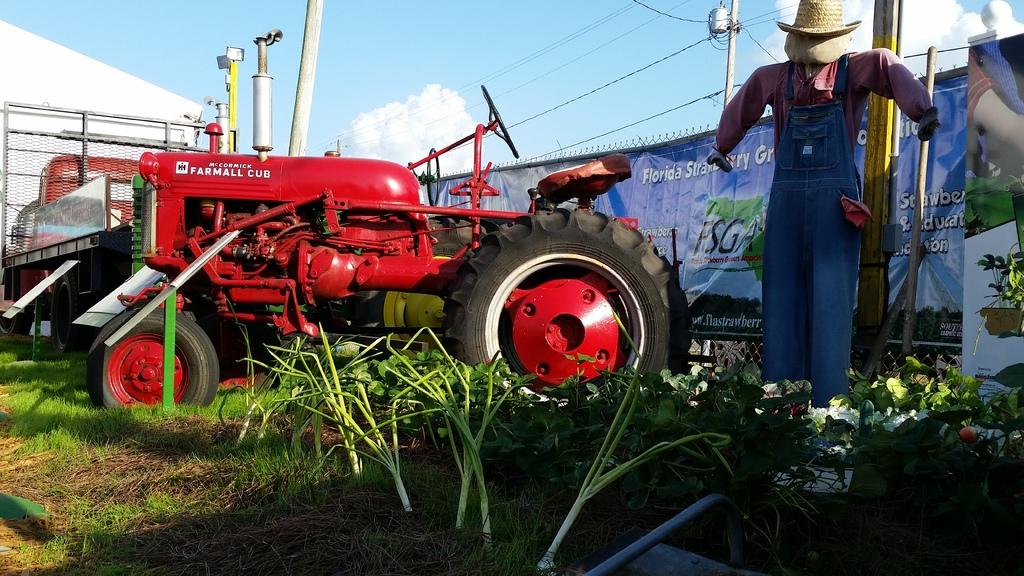What is the main subject of the image? The main subject of the image is a tractor. What can be seen on the ground in the image? There are plants and grass on the ground in the image. What is attached to the poles in the image? There is a banner attached to the poles in the image. What is the weather like in the image? The sky is cloudy in the image, indicating a potentially overcast or rainy day. What other structures are present in the image? There is a scarecrow and a house in the image. Where is the crate of nuts stored in the image? There is no crate of nuts present in the image. What type of grandmother is depicted in the image? There is no grandmother depicted in the image. 